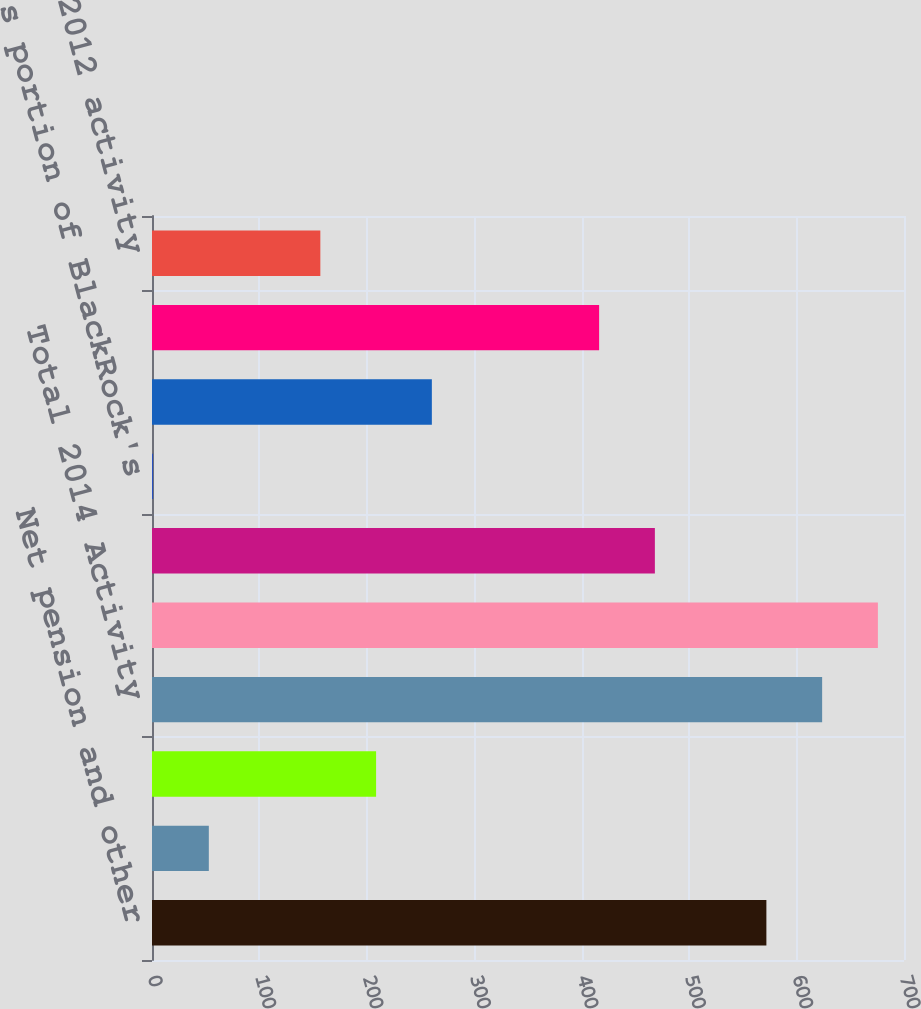Convert chart to OTSL. <chart><loc_0><loc_0><loc_500><loc_500><bar_chart><fcel>Net pension and other<fcel>Amortization of actuarial loss<fcel>Amortization of prior service<fcel>Total 2014 Activity<fcel>Balance at December 31 2014<fcel>Balance at December 31 2011<fcel>PNC's portion of BlackRock's<fcel>Net investment hedge<fcel>Foreign currency translation<fcel>Total 2012 activity<nl><fcel>571.9<fcel>52.9<fcel>208.6<fcel>623.8<fcel>675.7<fcel>468.1<fcel>1<fcel>260.5<fcel>416.2<fcel>156.7<nl></chart> 